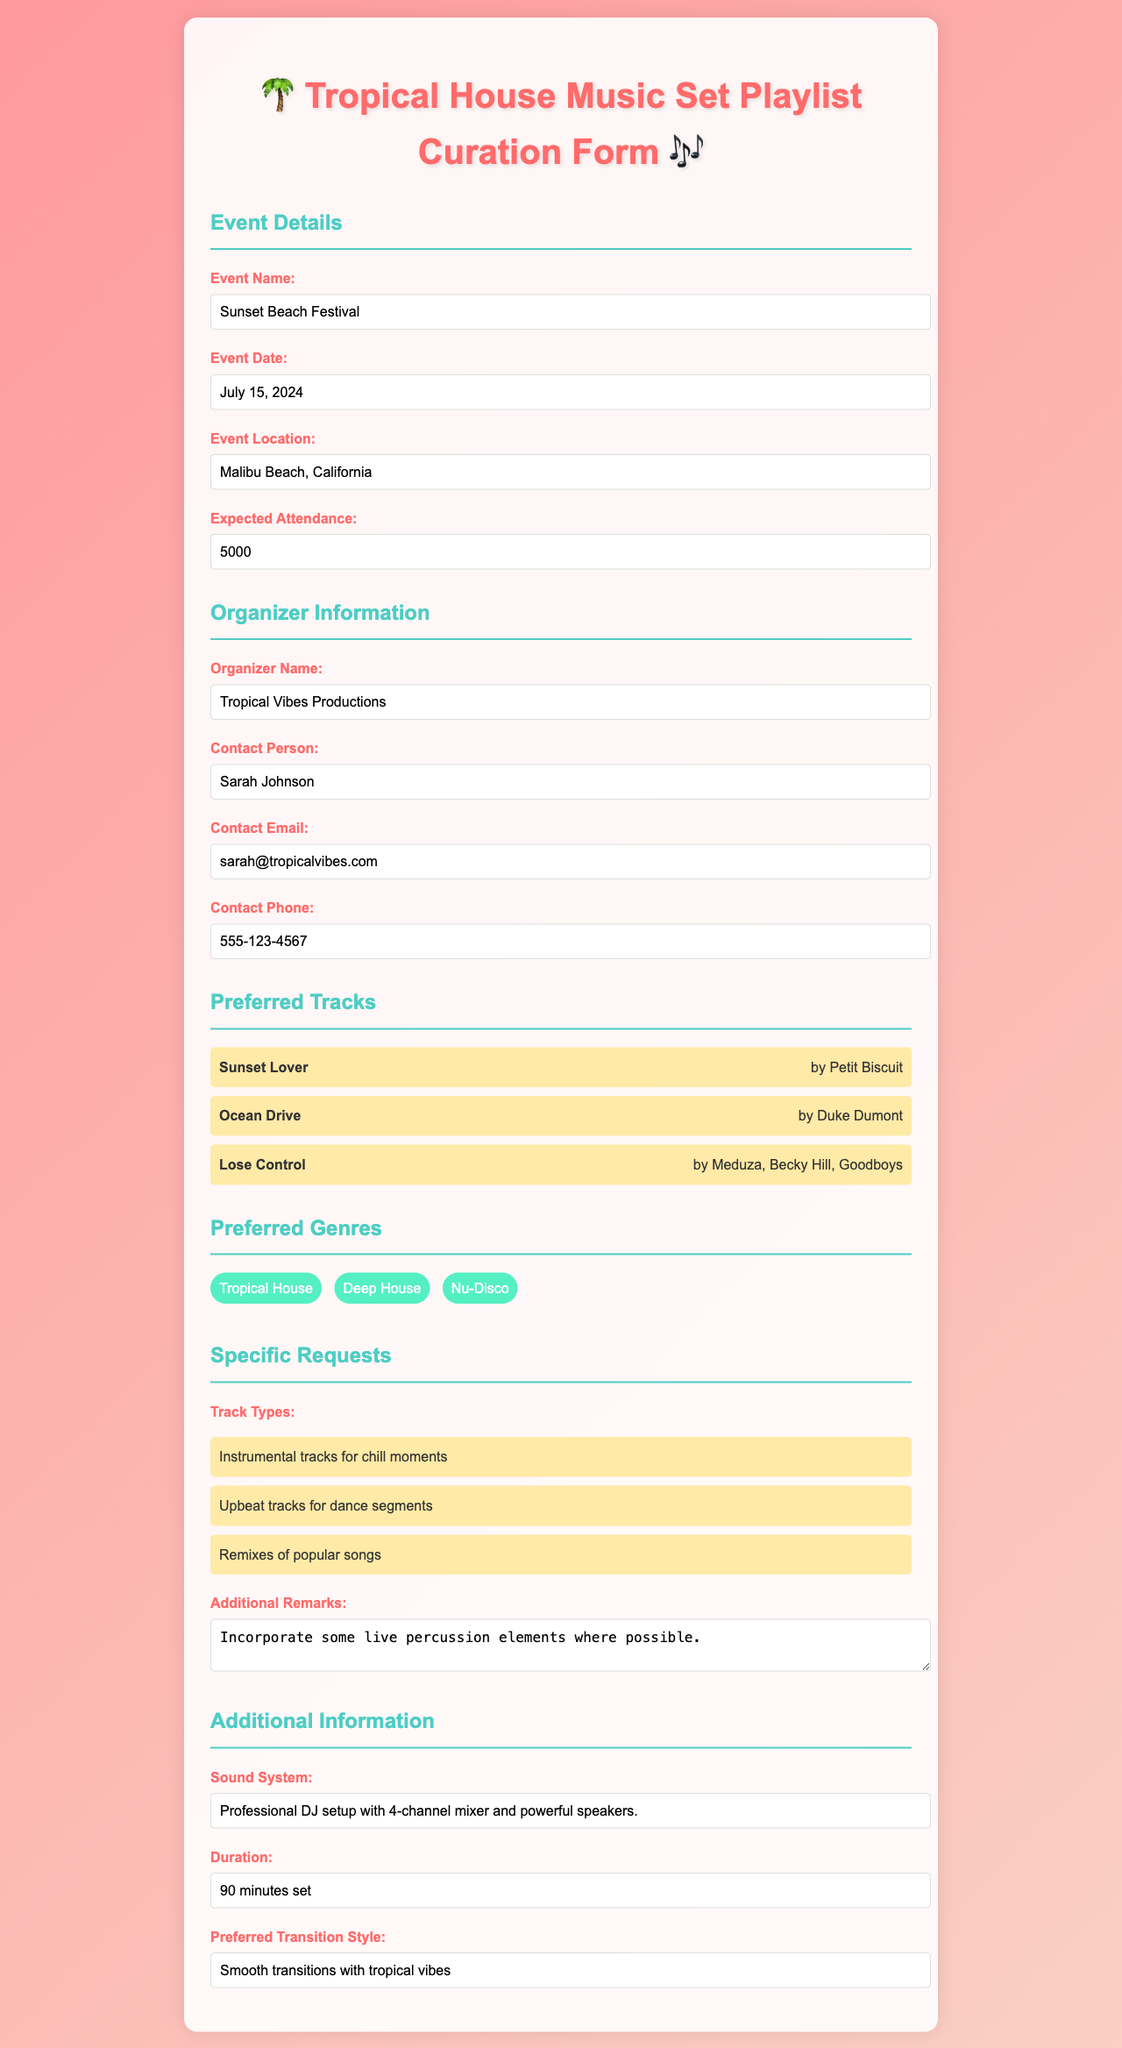What is the event name? The document lists the event name at the top under "Event Details."
Answer: Sunset Beach Festival What is the expected attendance? The expected attendance is noted in the event details section.
Answer: 5000 Who is the contact person for the event? The contact person is specified under the organizer information section.
Answer: Sarah Johnson What genres are preferred for the music set? Preferred genres are listed in the genres section of the document.
Answer: Tropical House, Deep House, Nu-Disco What track type is requested for chill moments? Specific requests mention instrumental tracks for chill moments.
Answer: Instrumental tracks How long is the set duration? The set duration is provided in the additional information section.
Answer: 90 minutes set What type of sound system is used for the event? The sound system details are specified in the additional information section.
Answer: Professional DJ setup with 4-channel mixer and powerful speakers What is one additional remark for the DJ? The additional remarks section provides specific notes for the DJ.
Answer: Incorporate some live percussion elements where possible What transition style is preferred? The preferred transition style is mentioned in the additional information section.
Answer: Smooth transitions with tropical vibes 